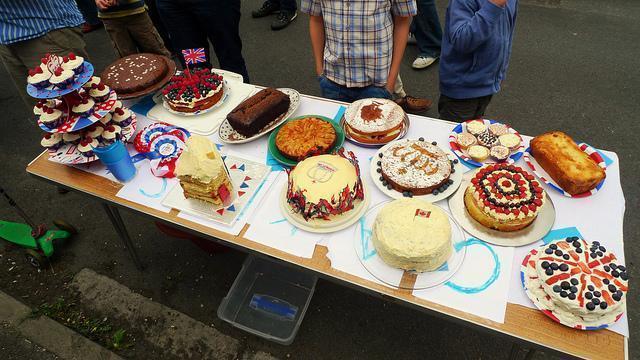The flag of what country is placed in the berry cake?
Choose the right answer from the provided options to respond to the question.
Options: United kingdom, france, sweden, germany. United kingdom. 